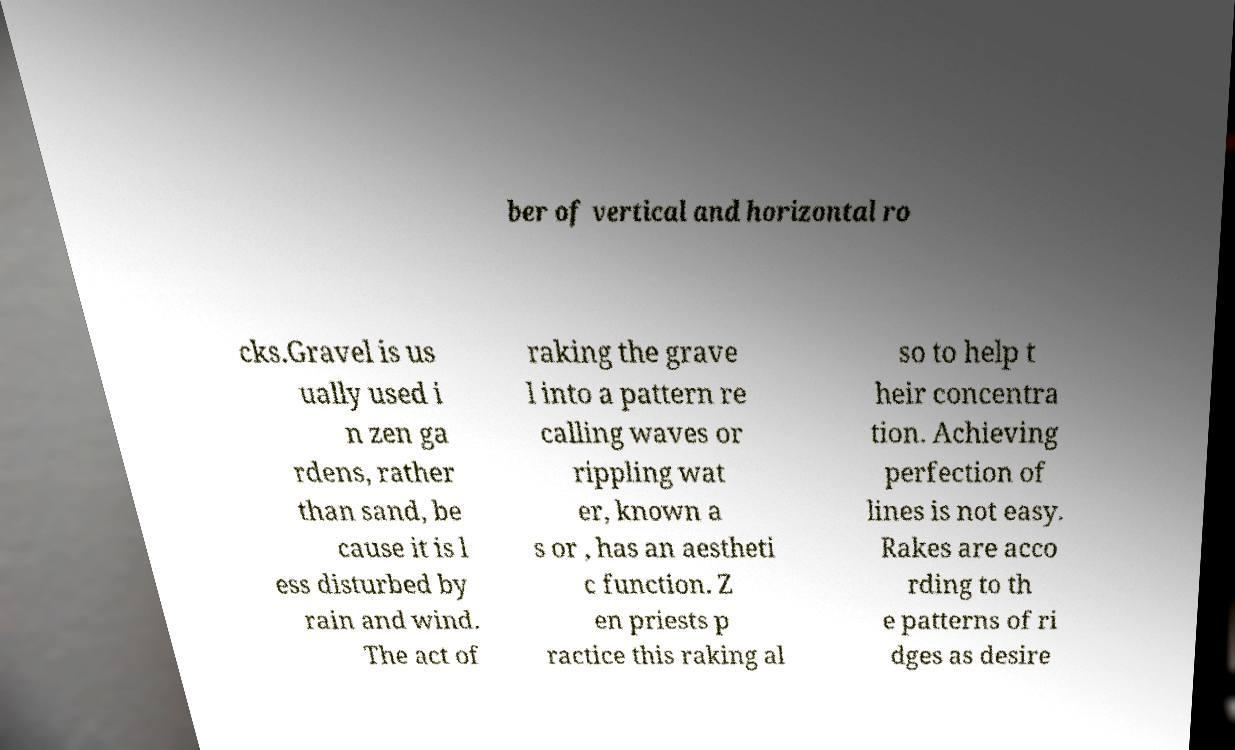Can you accurately transcribe the text from the provided image for me? ber of vertical and horizontal ro cks.Gravel is us ually used i n zen ga rdens, rather than sand, be cause it is l ess disturbed by rain and wind. The act of raking the grave l into a pattern re calling waves or rippling wat er, known a s or , has an aestheti c function. Z en priests p ractice this raking al so to help t heir concentra tion. Achieving perfection of lines is not easy. Rakes are acco rding to th e patterns of ri dges as desire 